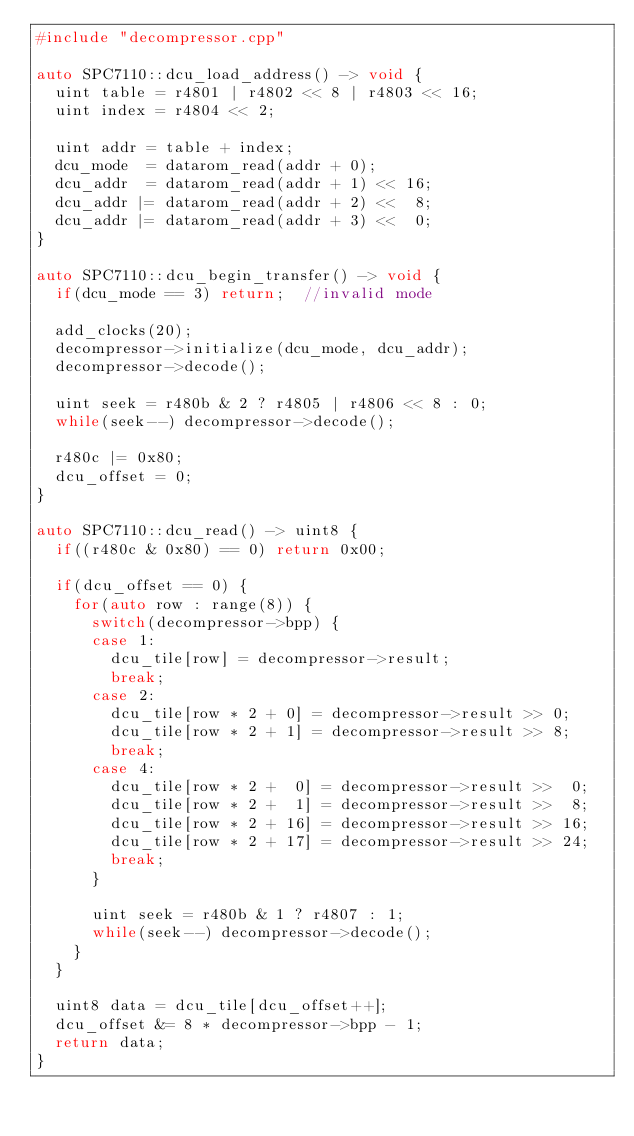<code> <loc_0><loc_0><loc_500><loc_500><_C++_>#include "decompressor.cpp"

auto SPC7110::dcu_load_address() -> void {
  uint table = r4801 | r4802 << 8 | r4803 << 16;
  uint index = r4804 << 2;

  uint addr = table + index;
  dcu_mode  = datarom_read(addr + 0);
  dcu_addr  = datarom_read(addr + 1) << 16;
  dcu_addr |= datarom_read(addr + 2) <<  8;
  dcu_addr |= datarom_read(addr + 3) <<  0;
}

auto SPC7110::dcu_begin_transfer() -> void {
  if(dcu_mode == 3) return;  //invalid mode

  add_clocks(20);
  decompressor->initialize(dcu_mode, dcu_addr);
  decompressor->decode();

  uint seek = r480b & 2 ? r4805 | r4806 << 8 : 0;
  while(seek--) decompressor->decode();

  r480c |= 0x80;
  dcu_offset = 0;
}

auto SPC7110::dcu_read() -> uint8 {
  if((r480c & 0x80) == 0) return 0x00;

  if(dcu_offset == 0) {
    for(auto row : range(8)) {
      switch(decompressor->bpp) {
      case 1:
        dcu_tile[row] = decompressor->result;
        break;
      case 2:
        dcu_tile[row * 2 + 0] = decompressor->result >> 0;
        dcu_tile[row * 2 + 1] = decompressor->result >> 8;
        break;
      case 4:
        dcu_tile[row * 2 +  0] = decompressor->result >>  0;
        dcu_tile[row * 2 +  1] = decompressor->result >>  8;
        dcu_tile[row * 2 + 16] = decompressor->result >> 16;
        dcu_tile[row * 2 + 17] = decompressor->result >> 24;
        break;
      }

      uint seek = r480b & 1 ? r4807 : 1;
      while(seek--) decompressor->decode();
    }
  }

  uint8 data = dcu_tile[dcu_offset++];
  dcu_offset &= 8 * decompressor->bpp - 1;
  return data;
}
</code> 